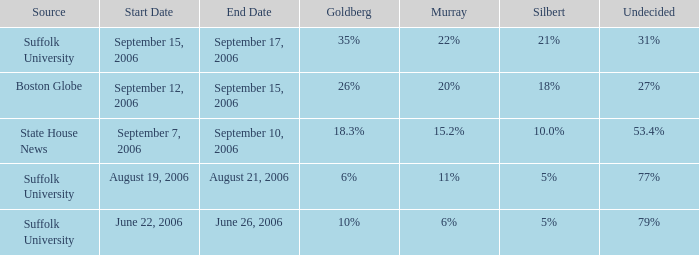0%? September 7–10, 2006. Would you mind parsing the complete table? {'header': ['Source', 'Start Date', 'End Date', 'Goldberg', 'Murray', 'Silbert', 'Undecided'], 'rows': [['Suffolk University', 'September 15, 2006', 'September 17, 2006', '35%', '22%', '21%', '31%'], ['Boston Globe', 'September 12, 2006', 'September 15, 2006', '26%', '20%', '18%', '27%'], ['State House News', 'September 7, 2006', 'September 10, 2006', '18.3%', '15.2%', '10.0%', '53.4%'], ['Suffolk University', 'August 19, 2006', 'August 21, 2006', '6%', '11%', '5%', '77%'], ['Suffolk University', 'June 22, 2006', 'June 26, 2006', '10%', '6%', '5%', '79%']]} 